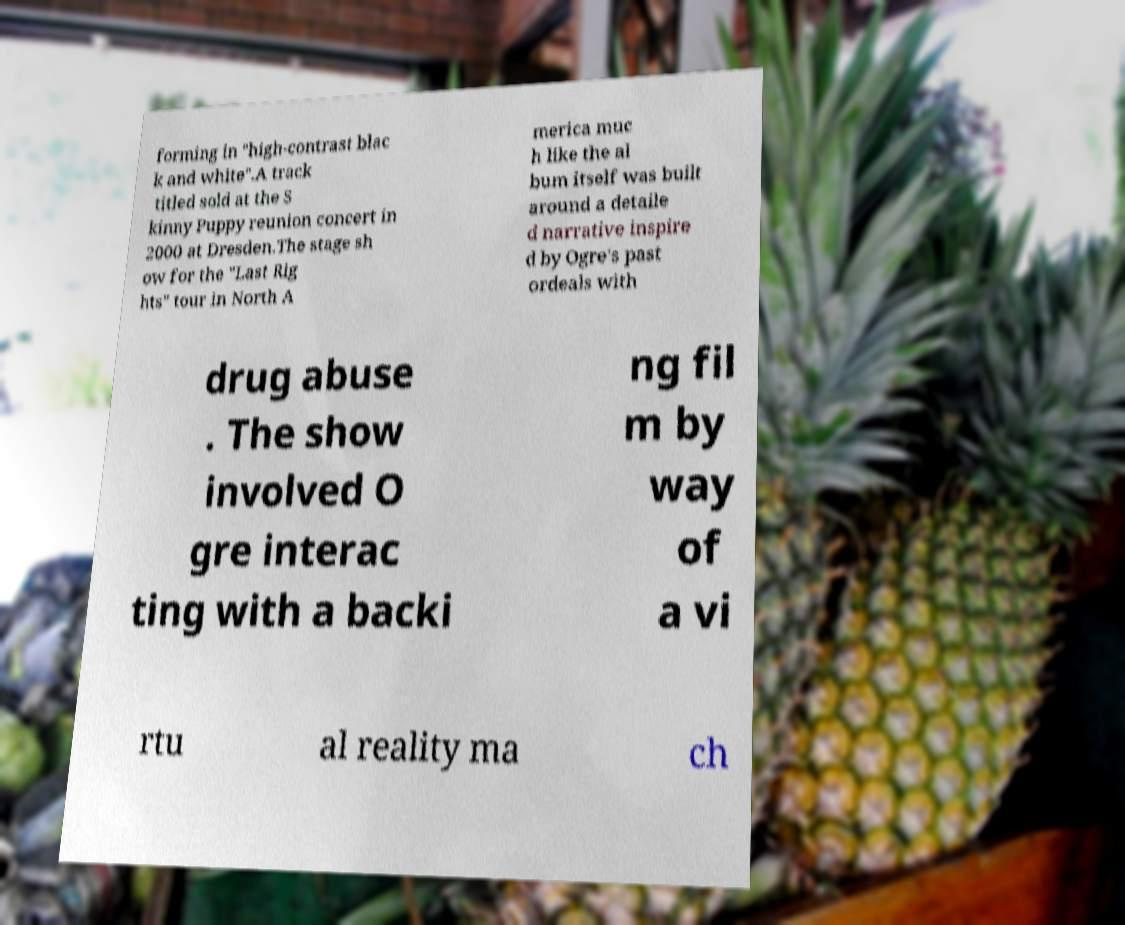Could you assist in decoding the text presented in this image and type it out clearly? forming in "high-contrast blac k and white".A track titled sold at the S kinny Puppy reunion concert in 2000 at Dresden.The stage sh ow for the "Last Rig hts" tour in North A merica muc h like the al bum itself was built around a detaile d narrative inspire d by Ogre's past ordeals with drug abuse . The show involved O gre interac ting with a backi ng fil m by way of a vi rtu al reality ma ch 